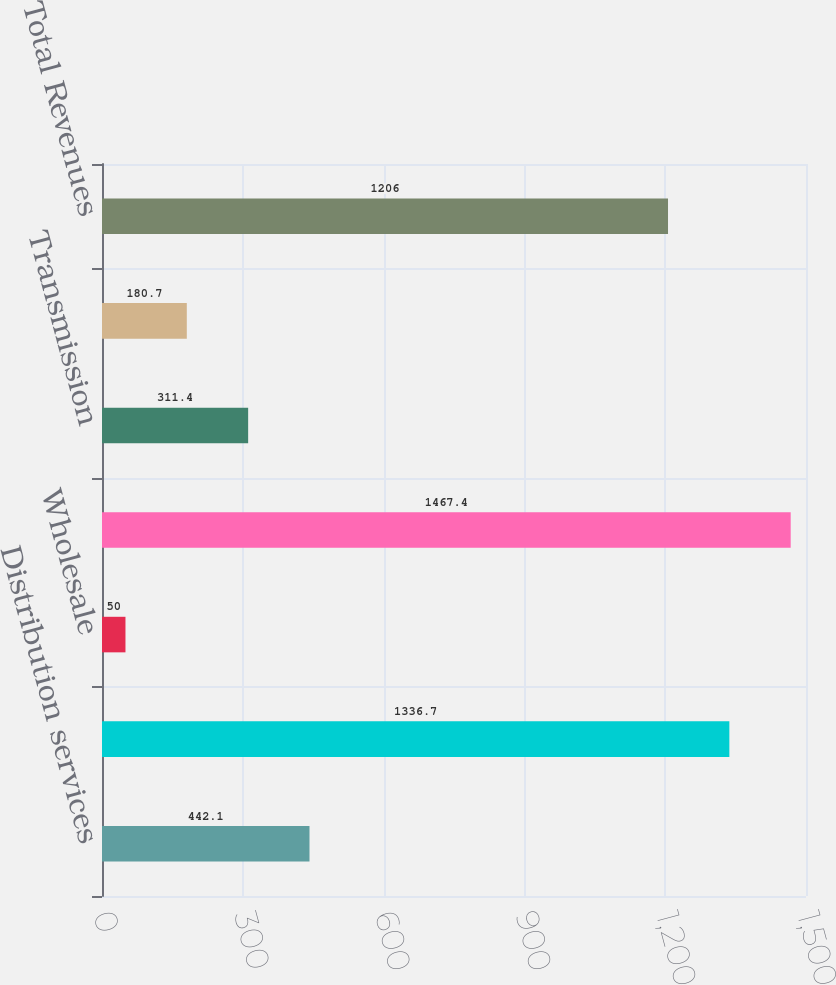Convert chart to OTSL. <chart><loc_0><loc_0><loc_500><loc_500><bar_chart><fcel>Distribution services<fcel>Retail<fcel>Wholesale<fcel>Total generation sales<fcel>Transmission<fcel>Other<fcel>Total Revenues<nl><fcel>442.1<fcel>1336.7<fcel>50<fcel>1467.4<fcel>311.4<fcel>180.7<fcel>1206<nl></chart> 